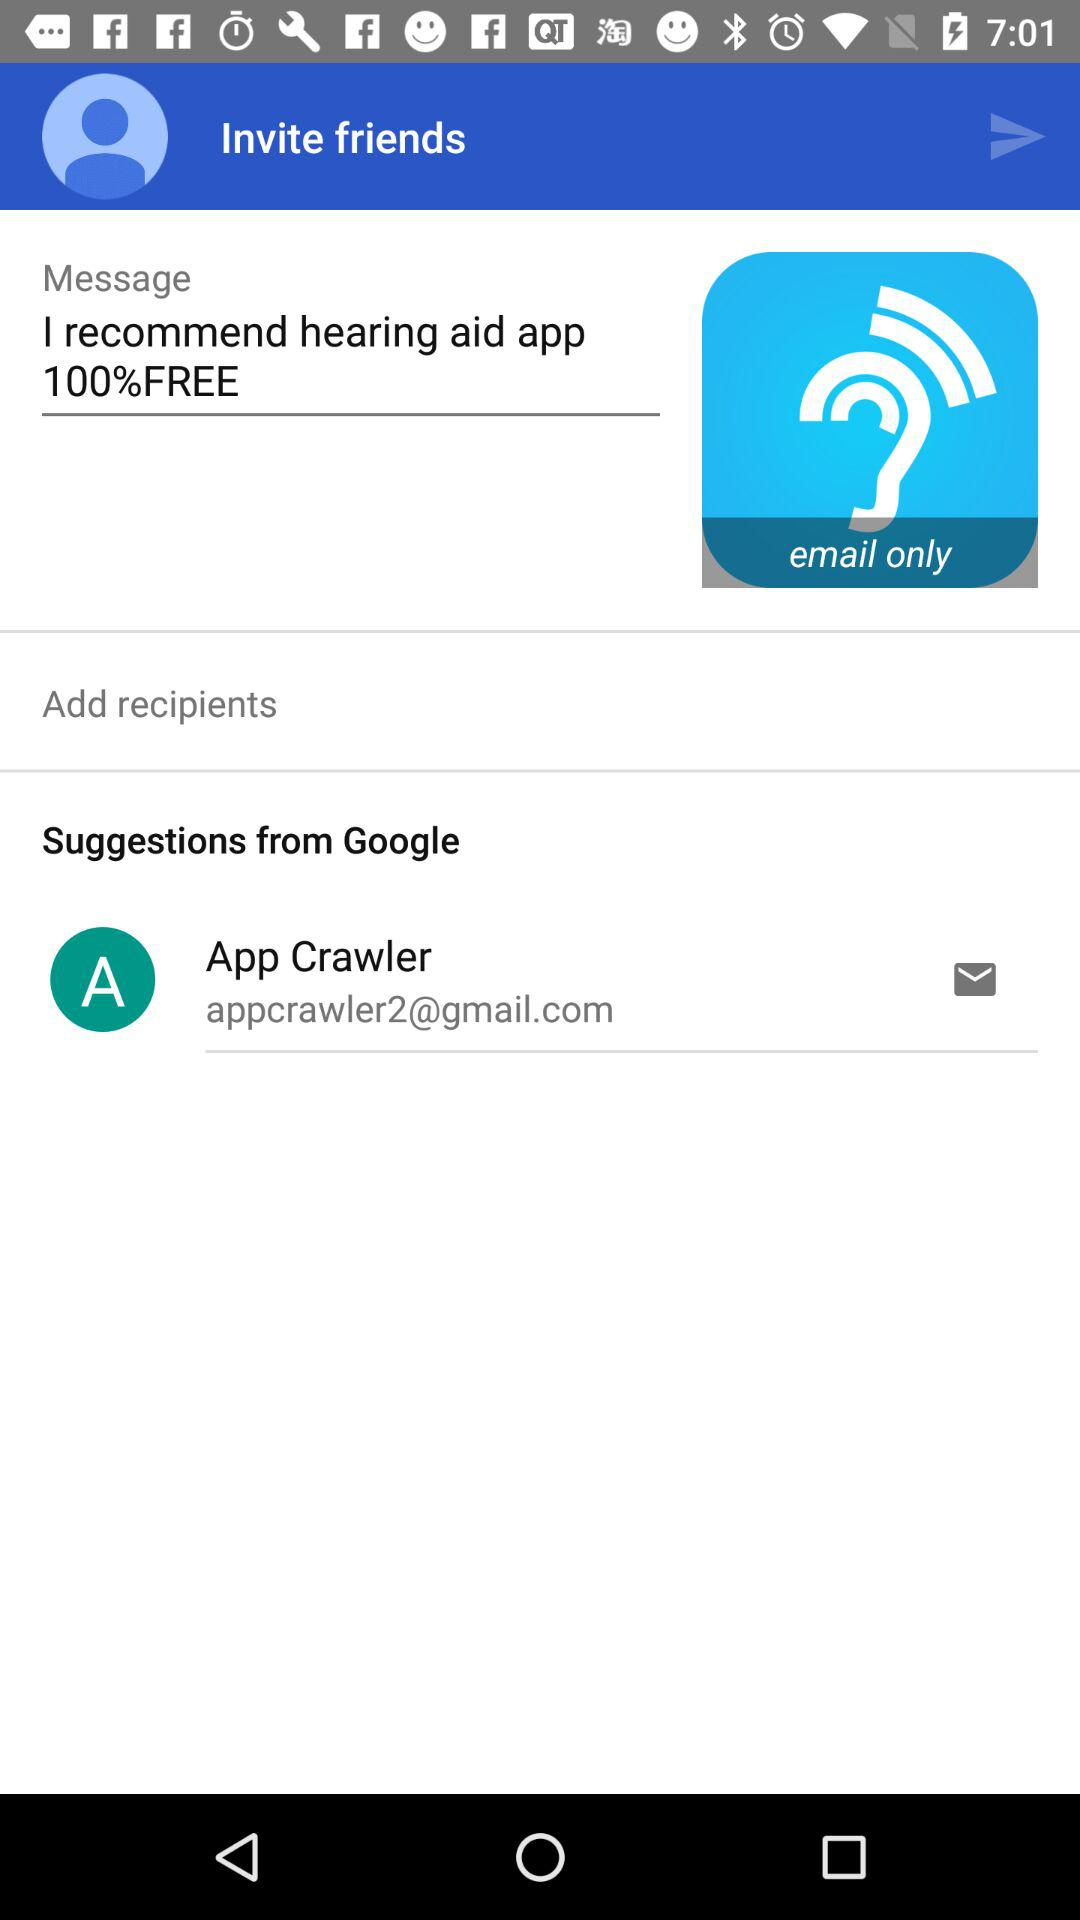What is the message written there? The written message is "I recommend hearing aid app 100%FREE". 